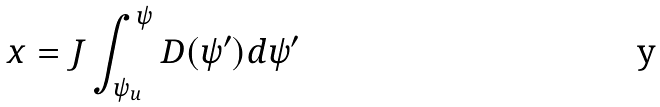<formula> <loc_0><loc_0><loc_500><loc_500>x = J \int _ { \psi _ { u } } ^ { \psi } D ( \psi ^ { \prime } ) d \psi ^ { \prime }</formula> 